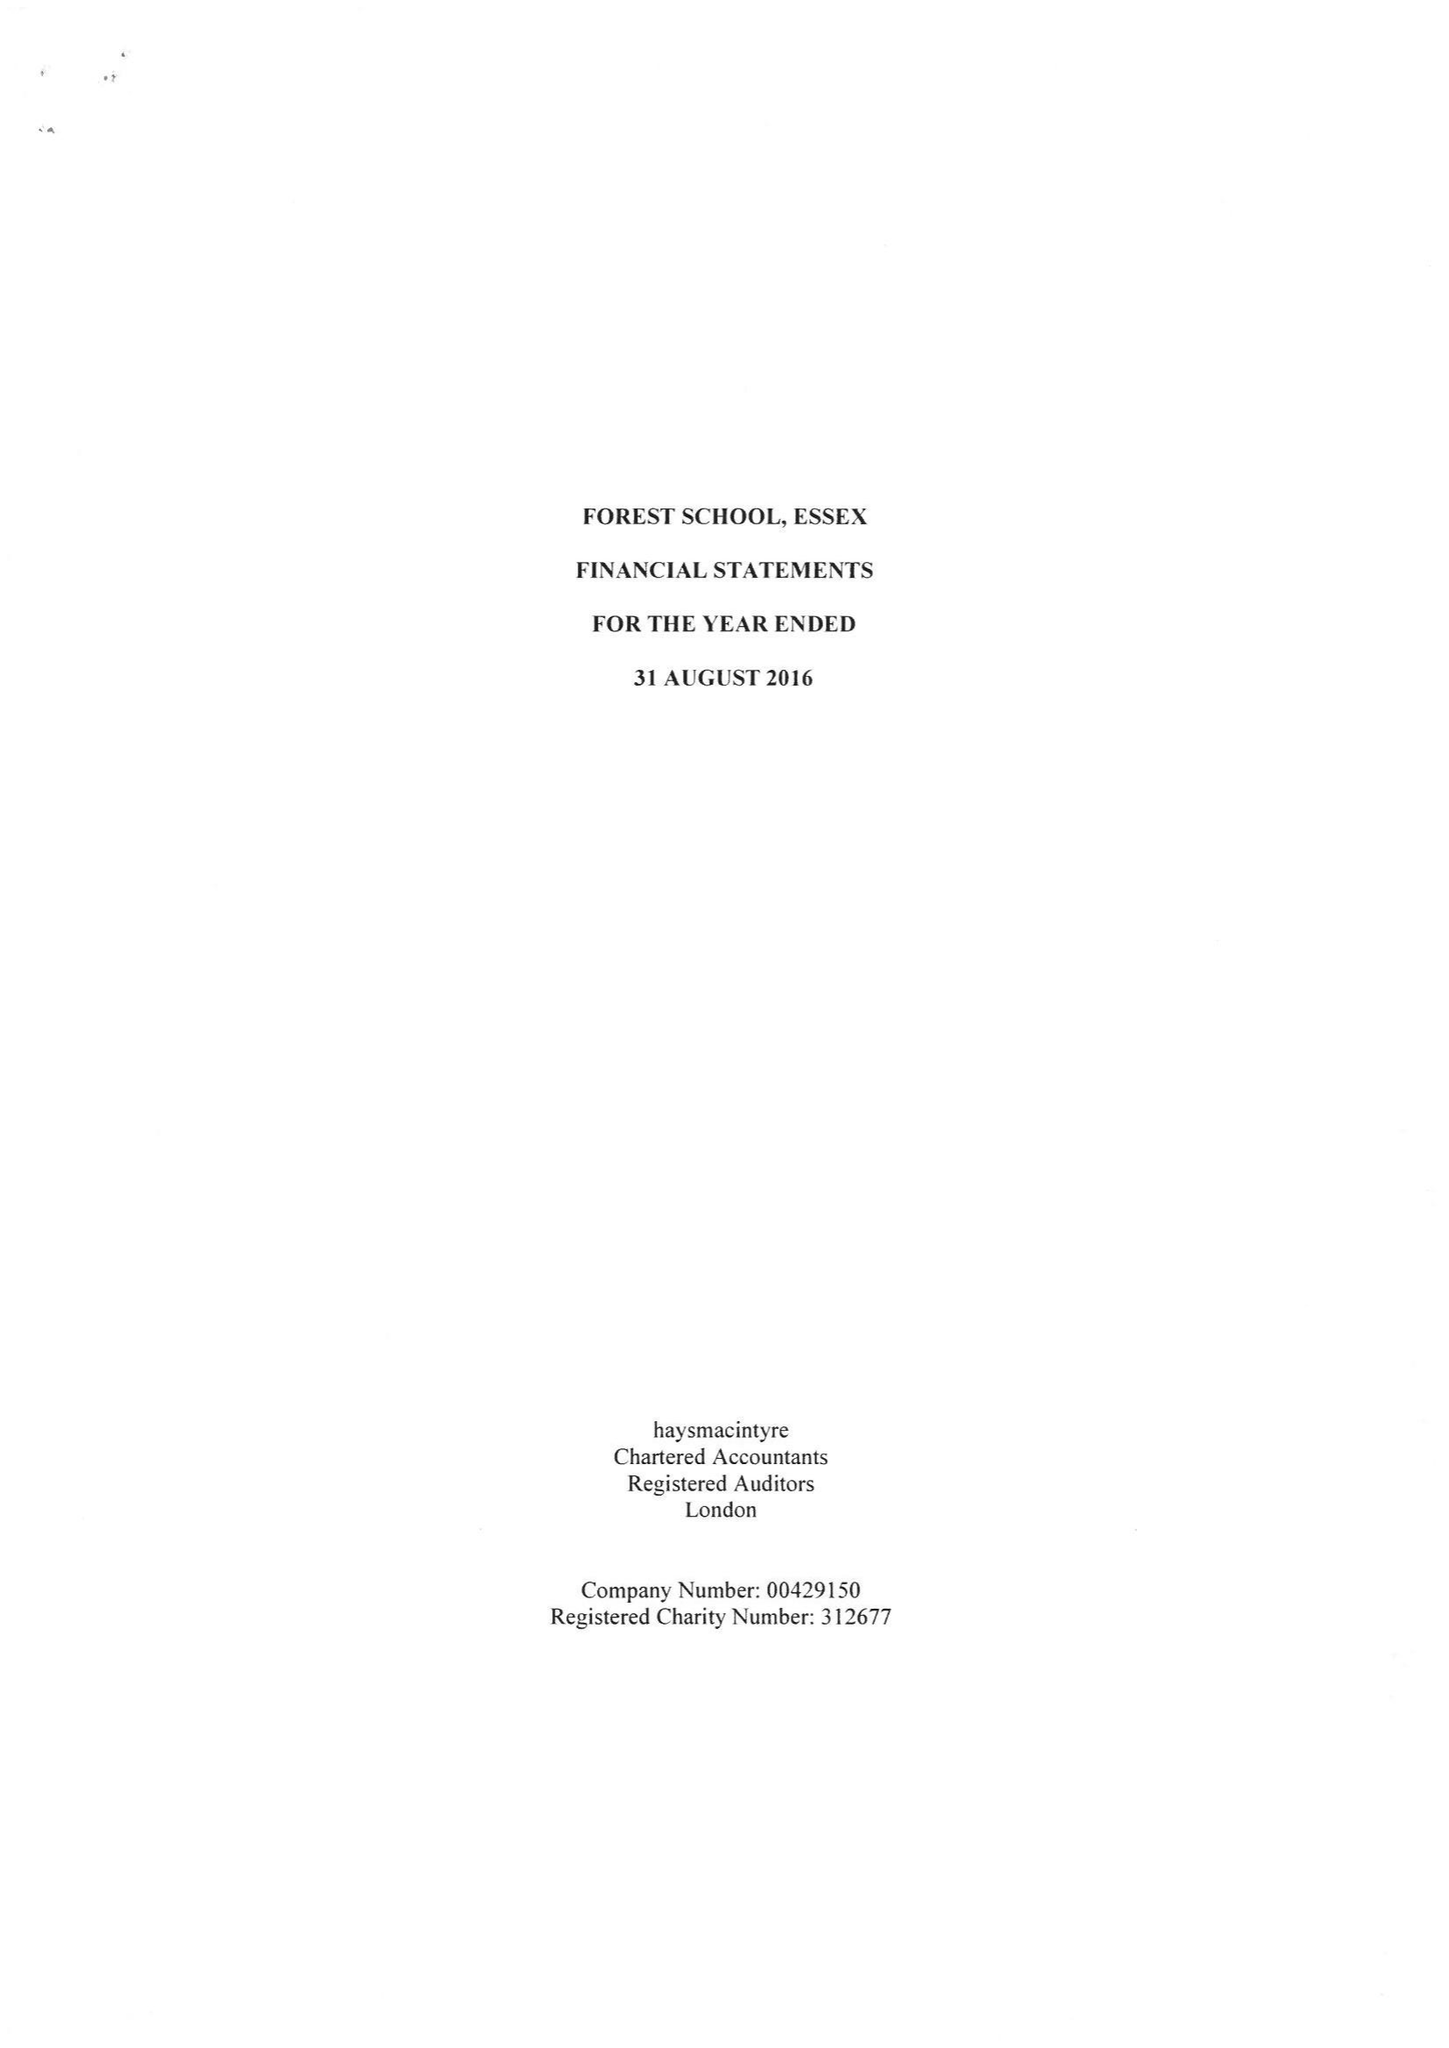What is the value for the income_annually_in_british_pounds?
Answer the question using a single word or phrase. 20852975.00 